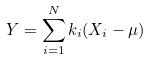Convert formula to latex. <formula><loc_0><loc_0><loc_500><loc_500>Y = \sum _ { i = 1 } ^ { N } k _ { i } ( X _ { i } - \mu )</formula> 